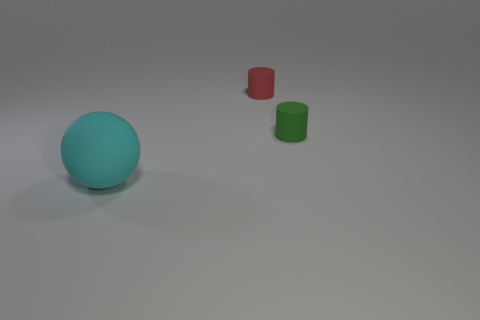Add 3 cyan balls. How many objects exist? 6 Subtract all cylinders. How many objects are left? 1 Add 2 small green things. How many small green things are left? 3 Add 1 matte things. How many matte things exist? 4 Subtract 0 red cubes. How many objects are left? 3 Subtract all big green blocks. Subtract all rubber balls. How many objects are left? 2 